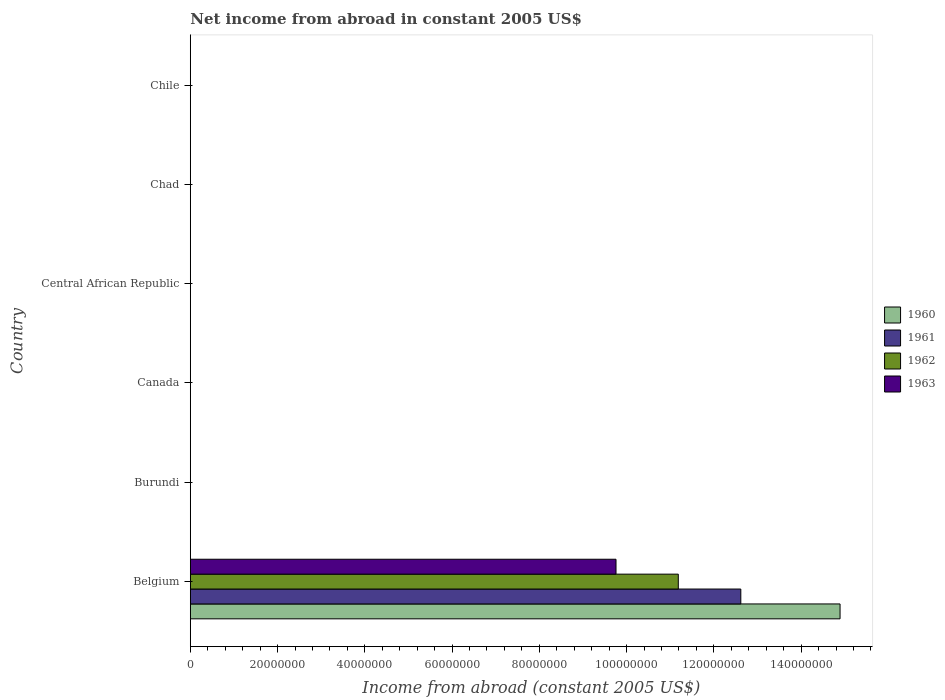Are the number of bars on each tick of the Y-axis equal?
Offer a terse response. No. What is the label of the 3rd group of bars from the top?
Provide a short and direct response. Central African Republic. Across all countries, what is the maximum net income from abroad in 1961?
Keep it short and to the point. 1.26e+08. In which country was the net income from abroad in 1961 maximum?
Offer a very short reply. Belgium. What is the total net income from abroad in 1961 in the graph?
Your answer should be very brief. 1.26e+08. What is the difference between the net income from abroad in 1961 in Chad and the net income from abroad in 1962 in Belgium?
Make the answer very short. -1.12e+08. What is the average net income from abroad in 1960 per country?
Give a very brief answer. 2.48e+07. What is the difference between the net income from abroad in 1960 and net income from abroad in 1962 in Belgium?
Offer a terse response. 3.71e+07. What is the difference between the highest and the lowest net income from abroad in 1961?
Your answer should be compact. 1.26e+08. Is it the case that in every country, the sum of the net income from abroad in 1961 and net income from abroad in 1960 is greater than the sum of net income from abroad in 1962 and net income from abroad in 1963?
Offer a very short reply. No. Is it the case that in every country, the sum of the net income from abroad in 1961 and net income from abroad in 1963 is greater than the net income from abroad in 1960?
Provide a succinct answer. No. How many bars are there?
Provide a short and direct response. 4. Are all the bars in the graph horizontal?
Keep it short and to the point. Yes. What is the difference between two consecutive major ticks on the X-axis?
Offer a very short reply. 2.00e+07. Are the values on the major ticks of X-axis written in scientific E-notation?
Give a very brief answer. No. Does the graph contain any zero values?
Keep it short and to the point. Yes. Where does the legend appear in the graph?
Ensure brevity in your answer.  Center right. What is the title of the graph?
Offer a very short reply. Net income from abroad in constant 2005 US$. Does "1995" appear as one of the legend labels in the graph?
Give a very brief answer. No. What is the label or title of the X-axis?
Ensure brevity in your answer.  Income from abroad (constant 2005 US$). What is the label or title of the Y-axis?
Your response must be concise. Country. What is the Income from abroad (constant 2005 US$) of 1960 in Belgium?
Offer a terse response. 1.49e+08. What is the Income from abroad (constant 2005 US$) of 1961 in Belgium?
Your answer should be compact. 1.26e+08. What is the Income from abroad (constant 2005 US$) in 1962 in Belgium?
Provide a succinct answer. 1.12e+08. What is the Income from abroad (constant 2005 US$) of 1963 in Belgium?
Give a very brief answer. 9.76e+07. What is the Income from abroad (constant 2005 US$) in 1960 in Burundi?
Your answer should be compact. 0. What is the Income from abroad (constant 2005 US$) of 1961 in Burundi?
Provide a succinct answer. 0. What is the Income from abroad (constant 2005 US$) of 1962 in Burundi?
Give a very brief answer. 0. What is the Income from abroad (constant 2005 US$) of 1963 in Burundi?
Offer a terse response. 0. What is the Income from abroad (constant 2005 US$) of 1960 in Canada?
Your answer should be compact. 0. What is the Income from abroad (constant 2005 US$) of 1962 in Canada?
Give a very brief answer. 0. What is the Income from abroad (constant 2005 US$) of 1961 in Central African Republic?
Your answer should be very brief. 0. What is the Income from abroad (constant 2005 US$) of 1962 in Central African Republic?
Keep it short and to the point. 0. What is the Income from abroad (constant 2005 US$) of 1962 in Chad?
Provide a succinct answer. 0. What is the Income from abroad (constant 2005 US$) of 1960 in Chile?
Offer a terse response. 0. What is the Income from abroad (constant 2005 US$) in 1961 in Chile?
Keep it short and to the point. 0. What is the Income from abroad (constant 2005 US$) of 1962 in Chile?
Give a very brief answer. 0. What is the Income from abroad (constant 2005 US$) in 1963 in Chile?
Keep it short and to the point. 0. Across all countries, what is the maximum Income from abroad (constant 2005 US$) in 1960?
Provide a succinct answer. 1.49e+08. Across all countries, what is the maximum Income from abroad (constant 2005 US$) of 1961?
Provide a succinct answer. 1.26e+08. Across all countries, what is the maximum Income from abroad (constant 2005 US$) in 1962?
Keep it short and to the point. 1.12e+08. Across all countries, what is the maximum Income from abroad (constant 2005 US$) in 1963?
Make the answer very short. 9.76e+07. Across all countries, what is the minimum Income from abroad (constant 2005 US$) in 1960?
Keep it short and to the point. 0. Across all countries, what is the minimum Income from abroad (constant 2005 US$) of 1961?
Make the answer very short. 0. Across all countries, what is the minimum Income from abroad (constant 2005 US$) of 1962?
Provide a short and direct response. 0. Across all countries, what is the minimum Income from abroad (constant 2005 US$) of 1963?
Ensure brevity in your answer.  0. What is the total Income from abroad (constant 2005 US$) in 1960 in the graph?
Ensure brevity in your answer.  1.49e+08. What is the total Income from abroad (constant 2005 US$) of 1961 in the graph?
Make the answer very short. 1.26e+08. What is the total Income from abroad (constant 2005 US$) of 1962 in the graph?
Your answer should be very brief. 1.12e+08. What is the total Income from abroad (constant 2005 US$) in 1963 in the graph?
Your response must be concise. 9.76e+07. What is the average Income from abroad (constant 2005 US$) in 1960 per country?
Make the answer very short. 2.48e+07. What is the average Income from abroad (constant 2005 US$) in 1961 per country?
Offer a very short reply. 2.10e+07. What is the average Income from abroad (constant 2005 US$) of 1962 per country?
Offer a terse response. 1.86e+07. What is the average Income from abroad (constant 2005 US$) in 1963 per country?
Keep it short and to the point. 1.63e+07. What is the difference between the Income from abroad (constant 2005 US$) of 1960 and Income from abroad (constant 2005 US$) of 1961 in Belgium?
Your answer should be compact. 2.27e+07. What is the difference between the Income from abroad (constant 2005 US$) in 1960 and Income from abroad (constant 2005 US$) in 1962 in Belgium?
Keep it short and to the point. 3.71e+07. What is the difference between the Income from abroad (constant 2005 US$) in 1960 and Income from abroad (constant 2005 US$) in 1963 in Belgium?
Offer a very short reply. 5.14e+07. What is the difference between the Income from abroad (constant 2005 US$) in 1961 and Income from abroad (constant 2005 US$) in 1962 in Belgium?
Your answer should be very brief. 1.43e+07. What is the difference between the Income from abroad (constant 2005 US$) of 1961 and Income from abroad (constant 2005 US$) of 1963 in Belgium?
Keep it short and to the point. 2.86e+07. What is the difference between the Income from abroad (constant 2005 US$) in 1962 and Income from abroad (constant 2005 US$) in 1963 in Belgium?
Make the answer very short. 1.43e+07. What is the difference between the highest and the lowest Income from abroad (constant 2005 US$) in 1960?
Provide a short and direct response. 1.49e+08. What is the difference between the highest and the lowest Income from abroad (constant 2005 US$) of 1961?
Ensure brevity in your answer.  1.26e+08. What is the difference between the highest and the lowest Income from abroad (constant 2005 US$) of 1962?
Offer a very short reply. 1.12e+08. What is the difference between the highest and the lowest Income from abroad (constant 2005 US$) in 1963?
Offer a terse response. 9.76e+07. 